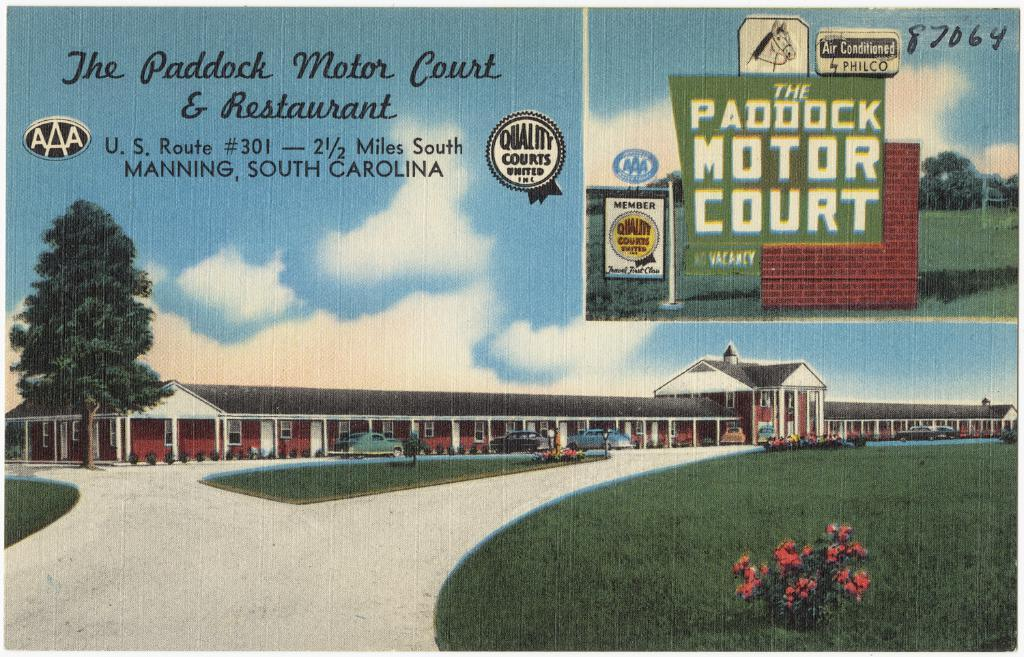<image>
Summarize the visual content of the image. An artistic rendition of the Paddock Motor Court in Manning, South Carolina. 